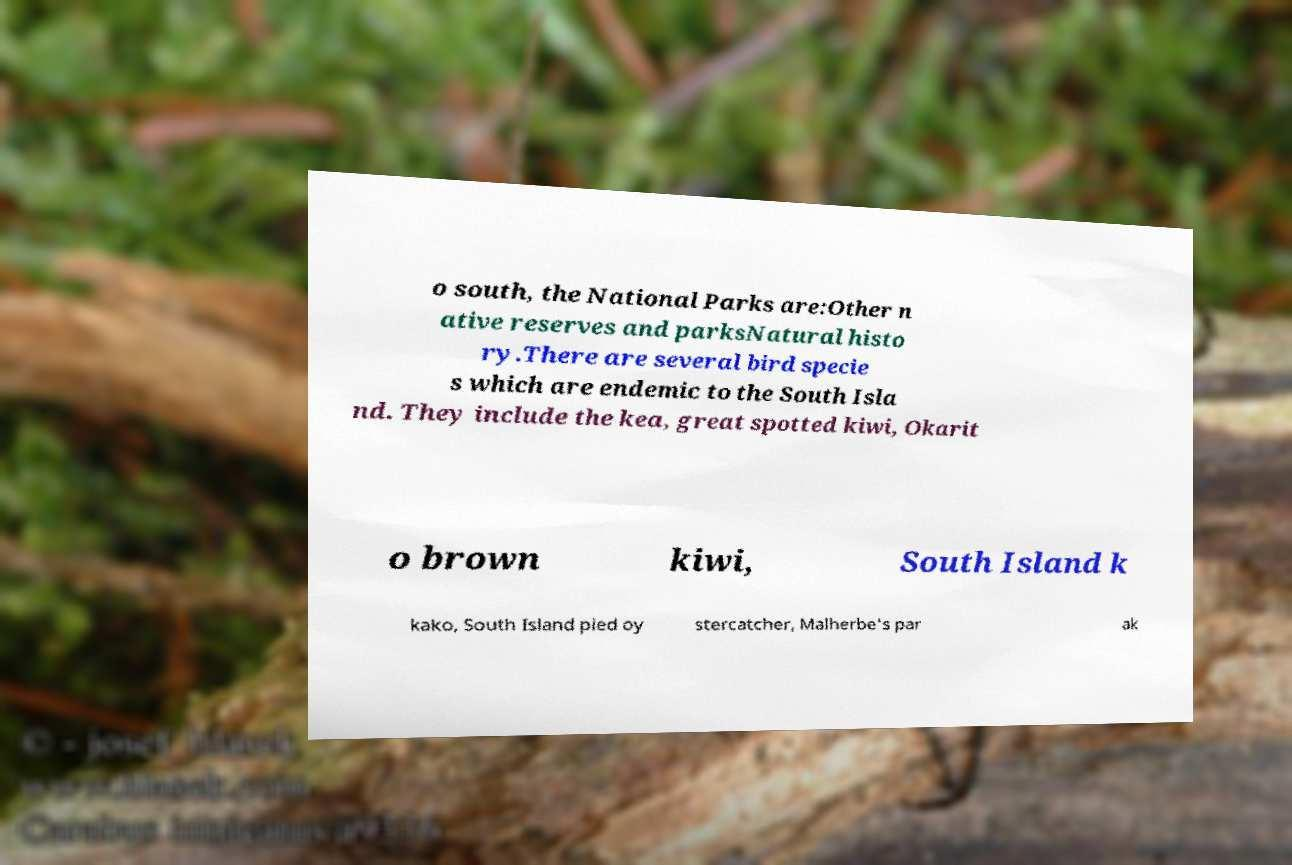For documentation purposes, I need the text within this image transcribed. Could you provide that? o south, the National Parks are:Other n ative reserves and parksNatural histo ry.There are several bird specie s which are endemic to the South Isla nd. They include the kea, great spotted kiwi, Okarit o brown kiwi, South Island k kako, South Island pied oy stercatcher, Malherbe's par ak 